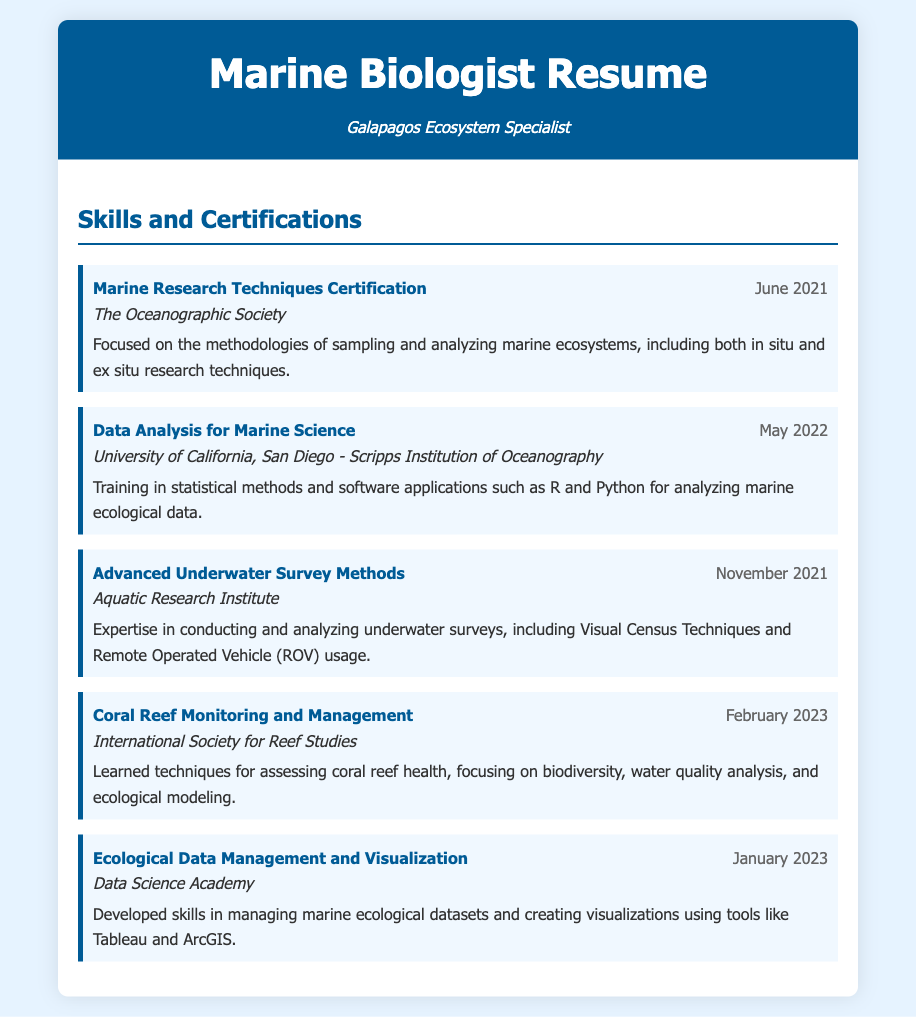What is the title of the certification obtained in June 2021? The title can be found in the skill-item section for the June 2021 certification.
Answer: Marine Research Techniques Certification Who awarded the certification for Data Analysis for Marine Science? The institution is listed under the corresponding skill-item for the May 2022 certification.
Answer: University of California, San Diego - Scripps Institution of Oceanography When was the Advanced Underwater Survey Methods certification acquired? The date is indicated next to the title of the certification in the skill-item.
Answer: November 2021 Which institution conducted the Coral Reef Monitoring and Management training? This information is provided under the skill-item for the February 2023 certification.
Answer: International Society for Reef Studies What is one of the statistical software applications mentioned in the Data Analysis for Marine Science certification? The software is listed in the description for that specific training.
Answer: R What are the primary focuses of the Coral Reef Monitoring and Management certification? The focuses are noted in the skill-description section of the relevant skill-item.
Answer: biodiversity, water quality analysis, and ecological modeling What type of underwater survey techniques did the Advanced Underwater Survey Methods certification cover? The types are mentioned in the description of the certification in the document.
Answer: Visual Census Techniques and Remote Operated Vehicle (ROV) usage Which skill certification was obtained most recently? This can be identified by comparing the dates of all certifications listed.
Answer: Coral Reef Monitoring and Management What is the main focus of the Marine Research Techniques Certification? The focus is outlined in the description of the certification.
Answer: methodologies of sampling and analyzing marine ecosystems 